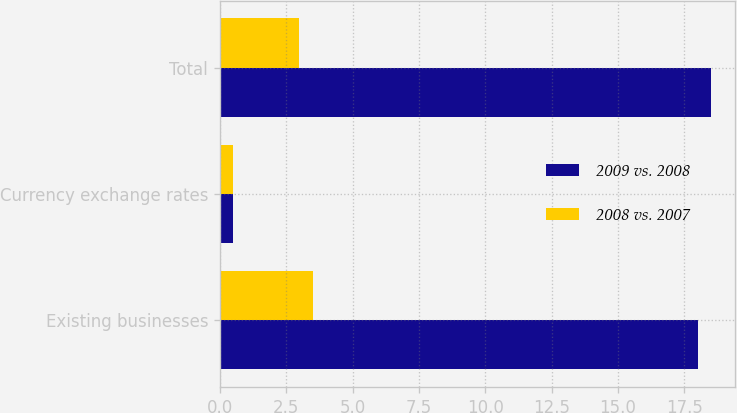Convert chart to OTSL. <chart><loc_0><loc_0><loc_500><loc_500><stacked_bar_chart><ecel><fcel>Existing businesses<fcel>Currency exchange rates<fcel>Total<nl><fcel>2009 vs. 2008<fcel>18<fcel>0.5<fcel>18.5<nl><fcel>2008 vs. 2007<fcel>3.5<fcel>0.5<fcel>3<nl></chart> 